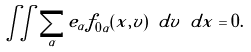<formula> <loc_0><loc_0><loc_500><loc_500>\iint \sum _ { \alpha } e _ { \alpha } f _ { 0 \alpha } ( x , v ) \ d v \ d x = 0 .</formula> 